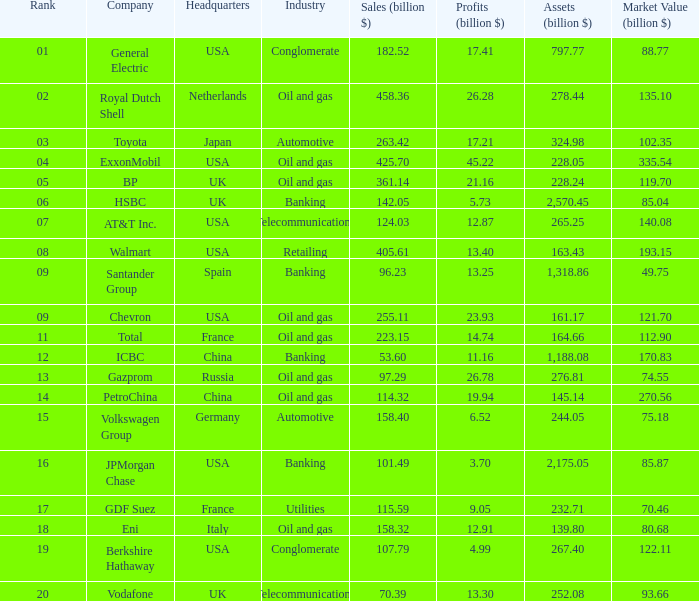Name the lowest Market Value (billion $) which has Assets (billion $) larger than 276.81, and a Company of toyota, and Profits (billion $) larger than 17.21? None. 